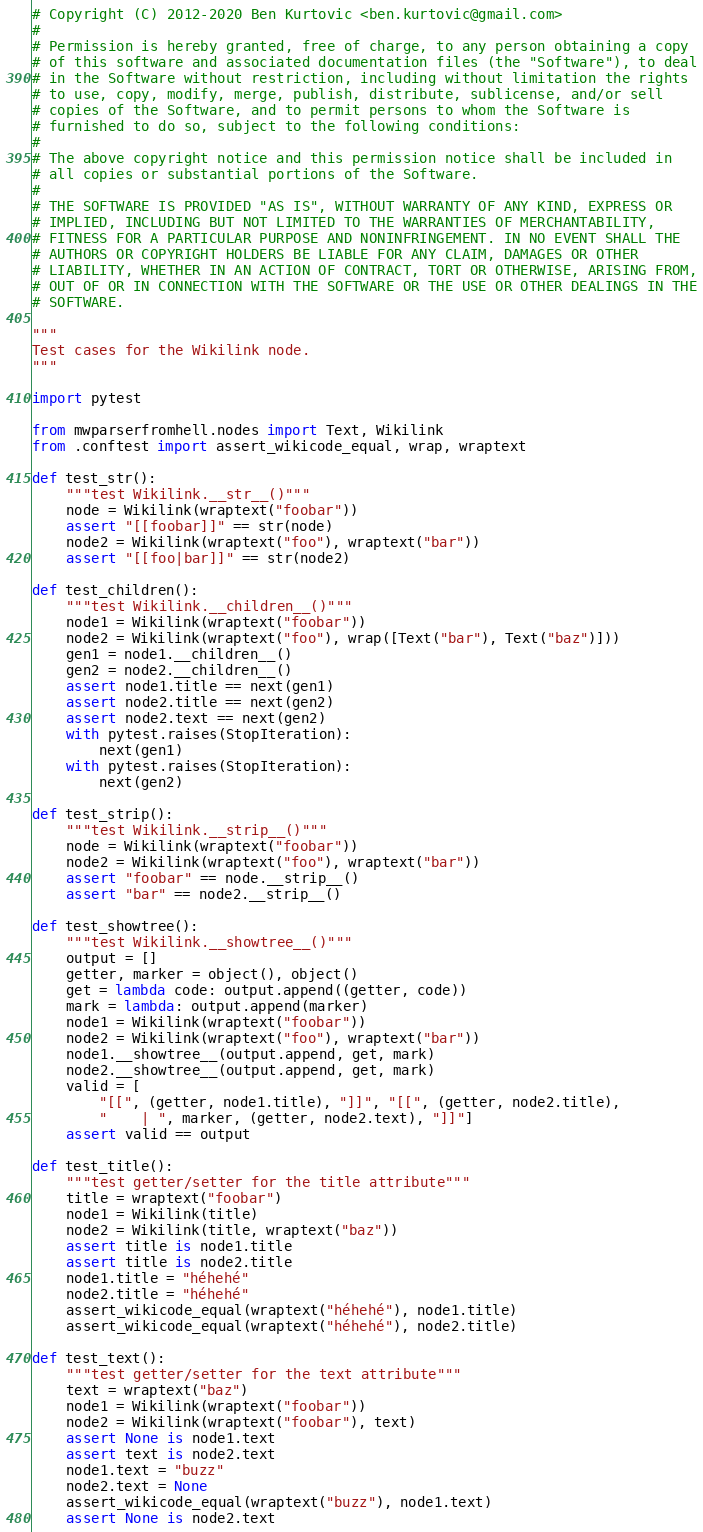<code> <loc_0><loc_0><loc_500><loc_500><_Python_># Copyright (C) 2012-2020 Ben Kurtovic <ben.kurtovic@gmail.com>
#
# Permission is hereby granted, free of charge, to any person obtaining a copy
# of this software and associated documentation files (the "Software"), to deal
# in the Software without restriction, including without limitation the rights
# to use, copy, modify, merge, publish, distribute, sublicense, and/or sell
# copies of the Software, and to permit persons to whom the Software is
# furnished to do so, subject to the following conditions:
#
# The above copyright notice and this permission notice shall be included in
# all copies or substantial portions of the Software.
#
# THE SOFTWARE IS PROVIDED "AS IS", WITHOUT WARRANTY OF ANY KIND, EXPRESS OR
# IMPLIED, INCLUDING BUT NOT LIMITED TO THE WARRANTIES OF MERCHANTABILITY,
# FITNESS FOR A PARTICULAR PURPOSE AND NONINFRINGEMENT. IN NO EVENT SHALL THE
# AUTHORS OR COPYRIGHT HOLDERS BE LIABLE FOR ANY CLAIM, DAMAGES OR OTHER
# LIABILITY, WHETHER IN AN ACTION OF CONTRACT, TORT OR OTHERWISE, ARISING FROM,
# OUT OF OR IN CONNECTION WITH THE SOFTWARE OR THE USE OR OTHER DEALINGS IN THE
# SOFTWARE.

"""
Test cases for the Wikilink node.
"""

import pytest

from mwparserfromhell.nodes import Text, Wikilink
from .conftest import assert_wikicode_equal, wrap, wraptext

def test_str():
    """test Wikilink.__str__()"""
    node = Wikilink(wraptext("foobar"))
    assert "[[foobar]]" == str(node)
    node2 = Wikilink(wraptext("foo"), wraptext("bar"))
    assert "[[foo|bar]]" == str(node2)

def test_children():
    """test Wikilink.__children__()"""
    node1 = Wikilink(wraptext("foobar"))
    node2 = Wikilink(wraptext("foo"), wrap([Text("bar"), Text("baz")]))
    gen1 = node1.__children__()
    gen2 = node2.__children__()
    assert node1.title == next(gen1)
    assert node2.title == next(gen2)
    assert node2.text == next(gen2)
    with pytest.raises(StopIteration):
        next(gen1)
    with pytest.raises(StopIteration):
        next(gen2)

def test_strip():
    """test Wikilink.__strip__()"""
    node = Wikilink(wraptext("foobar"))
    node2 = Wikilink(wraptext("foo"), wraptext("bar"))
    assert "foobar" == node.__strip__()
    assert "bar" == node2.__strip__()

def test_showtree():
    """test Wikilink.__showtree__()"""
    output = []
    getter, marker = object(), object()
    get = lambda code: output.append((getter, code))
    mark = lambda: output.append(marker)
    node1 = Wikilink(wraptext("foobar"))
    node2 = Wikilink(wraptext("foo"), wraptext("bar"))
    node1.__showtree__(output.append, get, mark)
    node2.__showtree__(output.append, get, mark)
    valid = [
        "[[", (getter, node1.title), "]]", "[[", (getter, node2.title),
        "    | ", marker, (getter, node2.text), "]]"]
    assert valid == output

def test_title():
    """test getter/setter for the title attribute"""
    title = wraptext("foobar")
    node1 = Wikilink(title)
    node2 = Wikilink(title, wraptext("baz"))
    assert title is node1.title
    assert title is node2.title
    node1.title = "héhehé"
    node2.title = "héhehé"
    assert_wikicode_equal(wraptext("héhehé"), node1.title)
    assert_wikicode_equal(wraptext("héhehé"), node2.title)

def test_text():
    """test getter/setter for the text attribute"""
    text = wraptext("baz")
    node1 = Wikilink(wraptext("foobar"))
    node2 = Wikilink(wraptext("foobar"), text)
    assert None is node1.text
    assert text is node2.text
    node1.text = "buzz"
    node2.text = None
    assert_wikicode_equal(wraptext("buzz"), node1.text)
    assert None is node2.text
</code> 